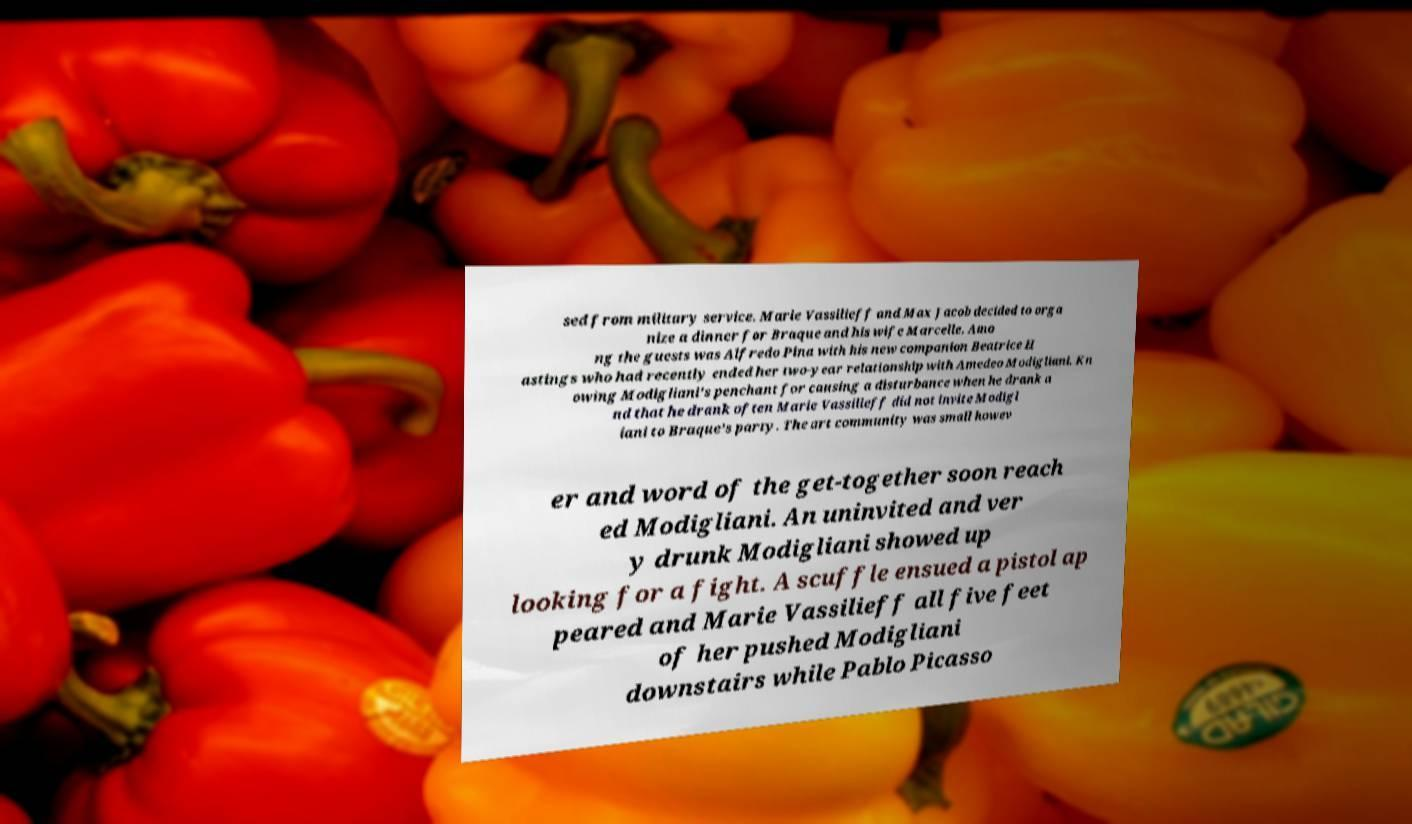For documentation purposes, I need the text within this image transcribed. Could you provide that? sed from military service. Marie Vassilieff and Max Jacob decided to orga nize a dinner for Braque and his wife Marcelle. Amo ng the guests was Alfredo Pina with his new companion Beatrice H astings who had recently ended her two-year relationship with Amedeo Modigliani. Kn owing Modigliani's penchant for causing a disturbance when he drank a nd that he drank often Marie Vassilieff did not invite Modigl iani to Braque's party. The art community was small howev er and word of the get-together soon reach ed Modigliani. An uninvited and ver y drunk Modigliani showed up looking for a fight. A scuffle ensued a pistol ap peared and Marie Vassilieff all five feet of her pushed Modigliani downstairs while Pablo Picasso 